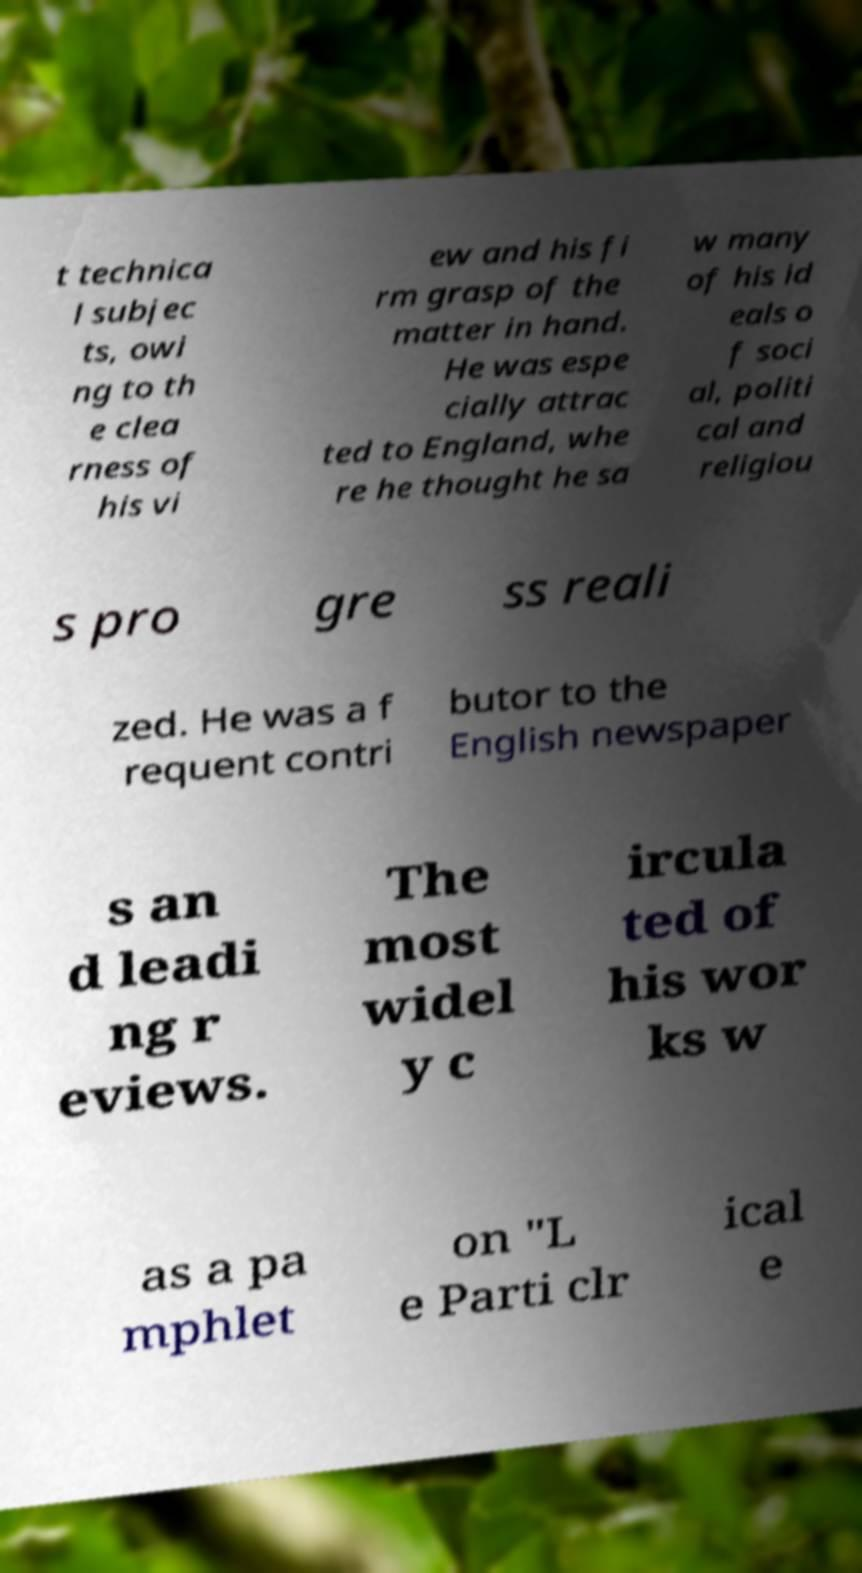There's text embedded in this image that I need extracted. Can you transcribe it verbatim? t technica l subjec ts, owi ng to th e clea rness of his vi ew and his fi rm grasp of the matter in hand. He was espe cially attrac ted to England, whe re he thought he sa w many of his id eals o f soci al, politi cal and religiou s pro gre ss reali zed. He was a f requent contri butor to the English newspaper s an d leadi ng r eviews. The most widel y c ircula ted of his wor ks w as a pa mphlet on "L e Parti clr ical e 